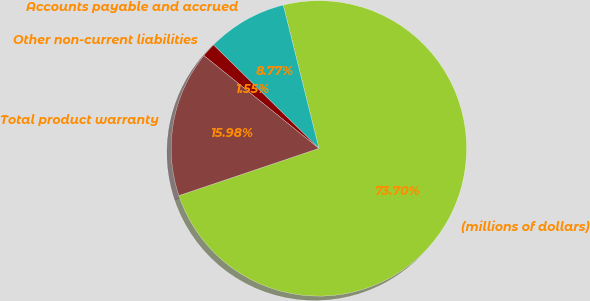<chart> <loc_0><loc_0><loc_500><loc_500><pie_chart><fcel>(millions of dollars)<fcel>Accounts payable and accrued<fcel>Other non-current liabilities<fcel>Total product warranty<nl><fcel>73.7%<fcel>8.77%<fcel>1.55%<fcel>15.98%<nl></chart> 